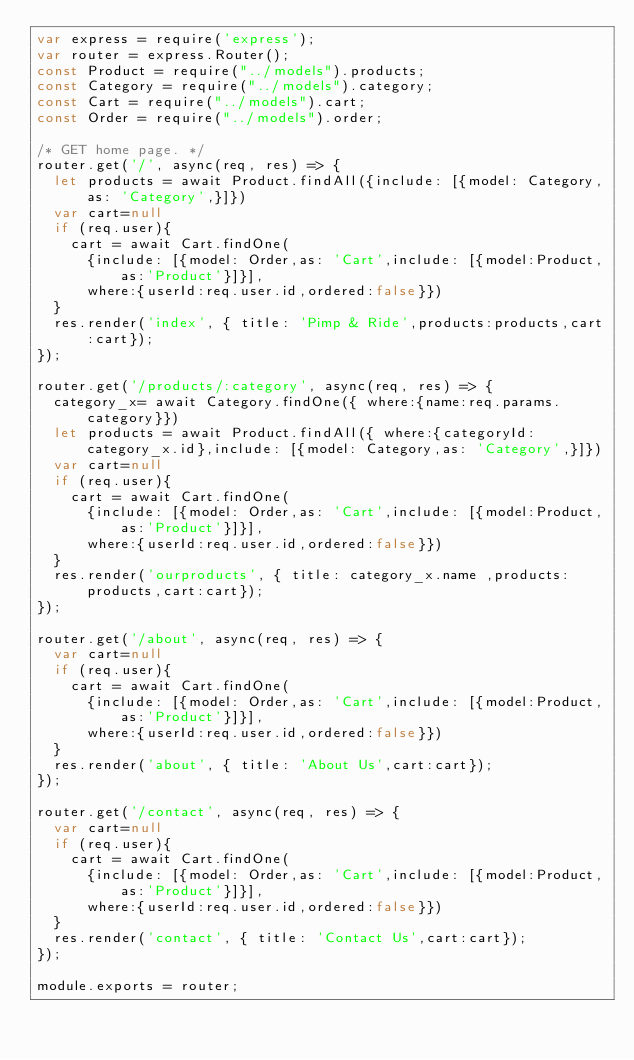<code> <loc_0><loc_0><loc_500><loc_500><_JavaScript_>var express = require('express');
var router = express.Router();
const Product = require("../models").products;
const Category = require("../models").category;
const Cart = require("../models").cart;
const Order = require("../models").order;

/* GET home page. */
router.get('/', async(req, res) => {  
  let products = await Product.findAll({include: [{model: Category,as: 'Category',}]})  
  var cart=null
  if (req.user){
    cart = await Cart.findOne(
      {include: [{model: Order,as: 'Cart',include: [{model:Product,as:'Product'}]}],
      where:{userId:req.user.id,ordered:false}})        
  }
  res.render('index', { title: 'Pimp & Ride',products:products,cart:cart});
});

router.get('/products/:category', async(req, res) => {  
  category_x= await Category.findOne({ where:{name:req.params.category}})  
  let products = await Product.findAll({ where:{categoryId:category_x.id},include: [{model: Category,as: 'Category',}]})  
  var cart=null
  if (req.user){
    cart = await Cart.findOne(
      {include: [{model: Order,as: 'Cart',include: [{model:Product,as:'Product'}]}],
      where:{userId:req.user.id,ordered:false}})        
  }
  res.render('ourproducts', { title: category_x.name ,products:products,cart:cart});
});

router.get('/about', async(req, res) => {
  var cart=null
  if (req.user){
    cart = await Cart.findOne(
      {include: [{model: Order,as: 'Cart',include: [{model:Product,as:'Product'}]}],
      where:{userId:req.user.id,ordered:false}})        
  }
  res.render('about', { title: 'About Us',cart:cart});
});

router.get('/contact', async(req, res) => {
  var cart=null
  if (req.user){
    cart = await Cart.findOne(
      {include: [{model: Order,as: 'Cart',include: [{model:Product,as:'Product'}]}],
      where:{userId:req.user.id,ordered:false}})        
  }
  res.render('contact', { title: 'Contact Us',cart:cart});
});

module.exports = router;
</code> 